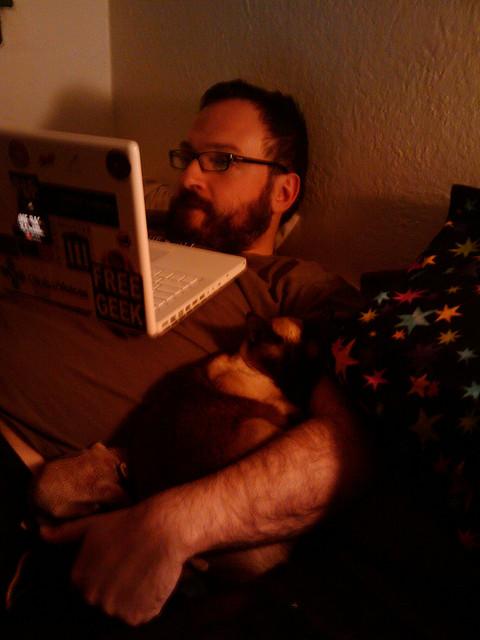Is there a grid pattern on the blanket?
Quick response, please. No. What does the person to the right have in their arms?
Be succinct. Cat. How many different star shapes are shown?
Answer briefly. 2. Is he using his laptop to shave his face?
Write a very short answer. No. What color are his glasses?
Write a very short answer. Black. How many of the papers in this photo look like bills?
Give a very brief answer. 0. 